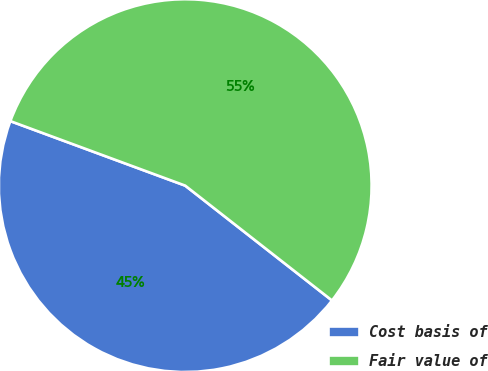Convert chart to OTSL. <chart><loc_0><loc_0><loc_500><loc_500><pie_chart><fcel>Cost basis of<fcel>Fair value of<nl><fcel>45.06%<fcel>54.94%<nl></chart> 